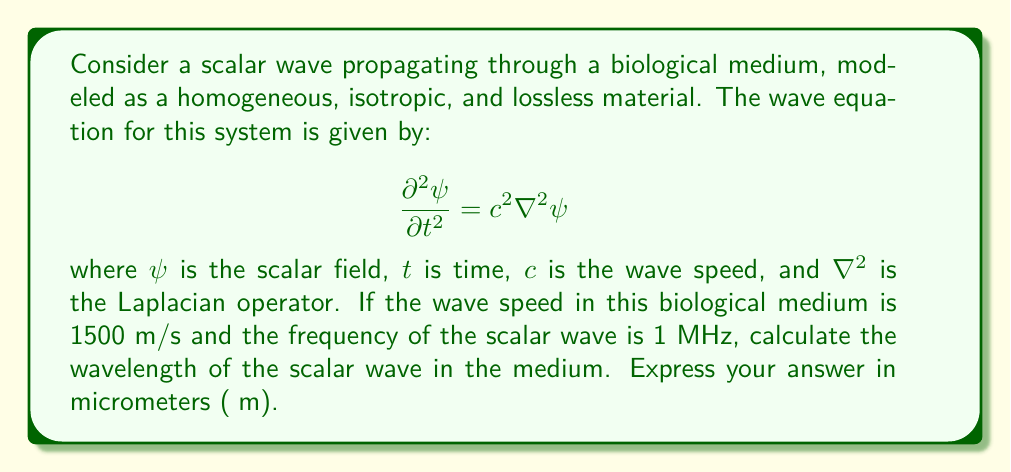Solve this math problem. To solve this problem, we'll follow these steps:

1) First, recall the relationship between wavelength ($\lambda$), frequency ($f$), and wave speed ($c$):

   $$c = \lambda f$$

2) We are given:
   - Wave speed: $c = 1500$ m/s
   - Frequency: $f = 1$ MHz = $1 \times 10^6$ Hz

3) Substituting these values into the equation:

   $$1500 = \lambda \times (1 \times 10^6)$$

4) Solving for $\lambda$:

   $$\lambda = \frac{1500}{1 \times 10^6} = 1.5 \times 10^{-3}\ \text{m}$$

5) Convert the result to micrometers:
   
   $$1.5 \times 10^{-3}\ \text{m} = 1.5 \times 10^3\ \mu\text{m} = 1500\ \mu\text{m}$$

Therefore, the wavelength of the scalar wave in the biological medium is 1500 μm.
Answer: 1500 μm 